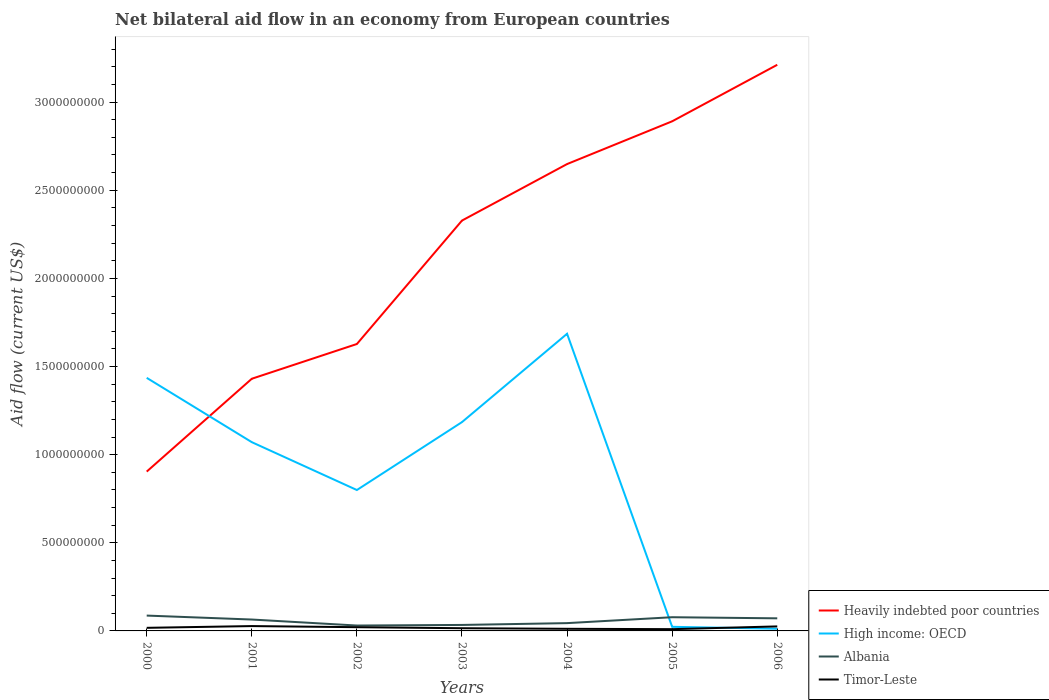Does the line corresponding to Timor-Leste intersect with the line corresponding to High income: OECD?
Offer a terse response. Yes. Across all years, what is the maximum net bilateral aid flow in High income: OECD?
Provide a short and direct response. 1.23e+07. What is the total net bilateral aid flow in Heavily indebted poor countries in the graph?
Offer a very short reply. -1.99e+09. What is the difference between the highest and the second highest net bilateral aid flow in High income: OECD?
Offer a terse response. 1.67e+09. Is the net bilateral aid flow in Albania strictly greater than the net bilateral aid flow in Heavily indebted poor countries over the years?
Your answer should be compact. Yes. How many years are there in the graph?
Offer a very short reply. 7. What is the difference between two consecutive major ticks on the Y-axis?
Your answer should be compact. 5.00e+08. Are the values on the major ticks of Y-axis written in scientific E-notation?
Provide a short and direct response. No. Does the graph contain any zero values?
Keep it short and to the point. No. Where does the legend appear in the graph?
Your answer should be compact. Bottom right. How are the legend labels stacked?
Provide a short and direct response. Vertical. What is the title of the graph?
Provide a short and direct response. Net bilateral aid flow in an economy from European countries. Does "Northern Mariana Islands" appear as one of the legend labels in the graph?
Offer a very short reply. No. What is the label or title of the Y-axis?
Offer a terse response. Aid flow (current US$). What is the Aid flow (current US$) in Heavily indebted poor countries in 2000?
Make the answer very short. 9.04e+08. What is the Aid flow (current US$) of High income: OECD in 2000?
Give a very brief answer. 1.44e+09. What is the Aid flow (current US$) in Albania in 2000?
Provide a succinct answer. 8.71e+07. What is the Aid flow (current US$) of Timor-Leste in 2000?
Ensure brevity in your answer.  1.75e+07. What is the Aid flow (current US$) in Heavily indebted poor countries in 2001?
Your answer should be very brief. 1.43e+09. What is the Aid flow (current US$) of High income: OECD in 2001?
Make the answer very short. 1.07e+09. What is the Aid flow (current US$) of Albania in 2001?
Your answer should be compact. 6.46e+07. What is the Aid flow (current US$) in Timor-Leste in 2001?
Make the answer very short. 2.75e+07. What is the Aid flow (current US$) in Heavily indebted poor countries in 2002?
Offer a terse response. 1.63e+09. What is the Aid flow (current US$) in High income: OECD in 2002?
Make the answer very short. 7.99e+08. What is the Aid flow (current US$) in Albania in 2002?
Give a very brief answer. 3.06e+07. What is the Aid flow (current US$) of Timor-Leste in 2002?
Give a very brief answer. 2.12e+07. What is the Aid flow (current US$) of Heavily indebted poor countries in 2003?
Your answer should be compact. 2.33e+09. What is the Aid flow (current US$) of High income: OECD in 2003?
Your response must be concise. 1.18e+09. What is the Aid flow (current US$) in Albania in 2003?
Keep it short and to the point. 3.39e+07. What is the Aid flow (current US$) of Timor-Leste in 2003?
Your answer should be compact. 1.53e+07. What is the Aid flow (current US$) of Heavily indebted poor countries in 2004?
Offer a terse response. 2.65e+09. What is the Aid flow (current US$) in High income: OECD in 2004?
Your answer should be very brief. 1.69e+09. What is the Aid flow (current US$) of Albania in 2004?
Give a very brief answer. 4.42e+07. What is the Aid flow (current US$) in Timor-Leste in 2004?
Keep it short and to the point. 1.21e+07. What is the Aid flow (current US$) of Heavily indebted poor countries in 2005?
Offer a terse response. 2.89e+09. What is the Aid flow (current US$) in High income: OECD in 2005?
Your answer should be compact. 2.33e+07. What is the Aid flow (current US$) of Albania in 2005?
Make the answer very short. 7.78e+07. What is the Aid flow (current US$) in Timor-Leste in 2005?
Provide a short and direct response. 9.97e+06. What is the Aid flow (current US$) in Heavily indebted poor countries in 2006?
Make the answer very short. 3.21e+09. What is the Aid flow (current US$) of High income: OECD in 2006?
Make the answer very short. 1.23e+07. What is the Aid flow (current US$) of Albania in 2006?
Offer a terse response. 7.14e+07. What is the Aid flow (current US$) in Timor-Leste in 2006?
Offer a very short reply. 2.56e+07. Across all years, what is the maximum Aid flow (current US$) in Heavily indebted poor countries?
Keep it short and to the point. 3.21e+09. Across all years, what is the maximum Aid flow (current US$) in High income: OECD?
Ensure brevity in your answer.  1.69e+09. Across all years, what is the maximum Aid flow (current US$) in Albania?
Give a very brief answer. 8.71e+07. Across all years, what is the maximum Aid flow (current US$) in Timor-Leste?
Keep it short and to the point. 2.75e+07. Across all years, what is the minimum Aid flow (current US$) in Heavily indebted poor countries?
Offer a very short reply. 9.04e+08. Across all years, what is the minimum Aid flow (current US$) of High income: OECD?
Offer a terse response. 1.23e+07. Across all years, what is the minimum Aid flow (current US$) of Albania?
Provide a short and direct response. 3.06e+07. Across all years, what is the minimum Aid flow (current US$) in Timor-Leste?
Provide a succinct answer. 9.97e+06. What is the total Aid flow (current US$) in Heavily indebted poor countries in the graph?
Offer a very short reply. 1.50e+1. What is the total Aid flow (current US$) of High income: OECD in the graph?
Your answer should be compact. 6.21e+09. What is the total Aid flow (current US$) of Albania in the graph?
Your response must be concise. 4.10e+08. What is the total Aid flow (current US$) of Timor-Leste in the graph?
Your response must be concise. 1.29e+08. What is the difference between the Aid flow (current US$) in Heavily indebted poor countries in 2000 and that in 2001?
Keep it short and to the point. -5.27e+08. What is the difference between the Aid flow (current US$) of High income: OECD in 2000 and that in 2001?
Your response must be concise. 3.65e+08. What is the difference between the Aid flow (current US$) of Albania in 2000 and that in 2001?
Offer a terse response. 2.25e+07. What is the difference between the Aid flow (current US$) in Timor-Leste in 2000 and that in 2001?
Your answer should be very brief. -9.96e+06. What is the difference between the Aid flow (current US$) of Heavily indebted poor countries in 2000 and that in 2002?
Your answer should be very brief. -7.24e+08. What is the difference between the Aid flow (current US$) of High income: OECD in 2000 and that in 2002?
Your response must be concise. 6.36e+08. What is the difference between the Aid flow (current US$) in Albania in 2000 and that in 2002?
Provide a short and direct response. 5.65e+07. What is the difference between the Aid flow (current US$) of Timor-Leste in 2000 and that in 2002?
Make the answer very short. -3.64e+06. What is the difference between the Aid flow (current US$) in Heavily indebted poor countries in 2000 and that in 2003?
Provide a succinct answer. -1.42e+09. What is the difference between the Aid flow (current US$) in High income: OECD in 2000 and that in 2003?
Your response must be concise. 2.51e+08. What is the difference between the Aid flow (current US$) in Albania in 2000 and that in 2003?
Keep it short and to the point. 5.32e+07. What is the difference between the Aid flow (current US$) in Timor-Leste in 2000 and that in 2003?
Offer a terse response. 2.21e+06. What is the difference between the Aid flow (current US$) of Heavily indebted poor countries in 2000 and that in 2004?
Your response must be concise. -1.74e+09. What is the difference between the Aid flow (current US$) of High income: OECD in 2000 and that in 2004?
Keep it short and to the point. -2.50e+08. What is the difference between the Aid flow (current US$) of Albania in 2000 and that in 2004?
Give a very brief answer. 4.28e+07. What is the difference between the Aid flow (current US$) of Timor-Leste in 2000 and that in 2004?
Give a very brief answer. 5.45e+06. What is the difference between the Aid flow (current US$) of Heavily indebted poor countries in 2000 and that in 2005?
Your response must be concise. -1.99e+09. What is the difference between the Aid flow (current US$) of High income: OECD in 2000 and that in 2005?
Offer a very short reply. 1.41e+09. What is the difference between the Aid flow (current US$) of Albania in 2000 and that in 2005?
Make the answer very short. 9.33e+06. What is the difference between the Aid flow (current US$) of Timor-Leste in 2000 and that in 2005?
Offer a very short reply. 7.56e+06. What is the difference between the Aid flow (current US$) in Heavily indebted poor countries in 2000 and that in 2006?
Ensure brevity in your answer.  -2.31e+09. What is the difference between the Aid flow (current US$) in High income: OECD in 2000 and that in 2006?
Your answer should be very brief. 1.42e+09. What is the difference between the Aid flow (current US$) of Albania in 2000 and that in 2006?
Provide a succinct answer. 1.57e+07. What is the difference between the Aid flow (current US$) of Timor-Leste in 2000 and that in 2006?
Provide a succinct answer. -8.06e+06. What is the difference between the Aid flow (current US$) of Heavily indebted poor countries in 2001 and that in 2002?
Offer a terse response. -1.97e+08. What is the difference between the Aid flow (current US$) of High income: OECD in 2001 and that in 2002?
Make the answer very short. 2.72e+08. What is the difference between the Aid flow (current US$) of Albania in 2001 and that in 2002?
Ensure brevity in your answer.  3.40e+07. What is the difference between the Aid flow (current US$) in Timor-Leste in 2001 and that in 2002?
Provide a short and direct response. 6.32e+06. What is the difference between the Aid flow (current US$) in Heavily indebted poor countries in 2001 and that in 2003?
Your response must be concise. -8.97e+08. What is the difference between the Aid flow (current US$) of High income: OECD in 2001 and that in 2003?
Keep it short and to the point. -1.14e+08. What is the difference between the Aid flow (current US$) of Albania in 2001 and that in 2003?
Make the answer very short. 3.07e+07. What is the difference between the Aid flow (current US$) in Timor-Leste in 2001 and that in 2003?
Your answer should be very brief. 1.22e+07. What is the difference between the Aid flow (current US$) in Heavily indebted poor countries in 2001 and that in 2004?
Give a very brief answer. -1.22e+09. What is the difference between the Aid flow (current US$) in High income: OECD in 2001 and that in 2004?
Your answer should be very brief. -6.15e+08. What is the difference between the Aid flow (current US$) in Albania in 2001 and that in 2004?
Your answer should be very brief. 2.04e+07. What is the difference between the Aid flow (current US$) in Timor-Leste in 2001 and that in 2004?
Keep it short and to the point. 1.54e+07. What is the difference between the Aid flow (current US$) in Heavily indebted poor countries in 2001 and that in 2005?
Your answer should be compact. -1.46e+09. What is the difference between the Aid flow (current US$) of High income: OECD in 2001 and that in 2005?
Give a very brief answer. 1.05e+09. What is the difference between the Aid flow (current US$) in Albania in 2001 and that in 2005?
Your answer should be compact. -1.32e+07. What is the difference between the Aid flow (current US$) of Timor-Leste in 2001 and that in 2005?
Your response must be concise. 1.75e+07. What is the difference between the Aid flow (current US$) in Heavily indebted poor countries in 2001 and that in 2006?
Your answer should be very brief. -1.78e+09. What is the difference between the Aid flow (current US$) in High income: OECD in 2001 and that in 2006?
Your answer should be very brief. 1.06e+09. What is the difference between the Aid flow (current US$) in Albania in 2001 and that in 2006?
Offer a very short reply. -6.81e+06. What is the difference between the Aid flow (current US$) of Timor-Leste in 2001 and that in 2006?
Provide a short and direct response. 1.90e+06. What is the difference between the Aid flow (current US$) of Heavily indebted poor countries in 2002 and that in 2003?
Offer a very short reply. -7.00e+08. What is the difference between the Aid flow (current US$) of High income: OECD in 2002 and that in 2003?
Your response must be concise. -3.85e+08. What is the difference between the Aid flow (current US$) of Albania in 2002 and that in 2003?
Make the answer very short. -3.29e+06. What is the difference between the Aid flow (current US$) of Timor-Leste in 2002 and that in 2003?
Provide a short and direct response. 5.85e+06. What is the difference between the Aid flow (current US$) of Heavily indebted poor countries in 2002 and that in 2004?
Make the answer very short. -1.02e+09. What is the difference between the Aid flow (current US$) of High income: OECD in 2002 and that in 2004?
Give a very brief answer. -8.86e+08. What is the difference between the Aid flow (current US$) of Albania in 2002 and that in 2004?
Your answer should be compact. -1.36e+07. What is the difference between the Aid flow (current US$) of Timor-Leste in 2002 and that in 2004?
Your answer should be very brief. 9.09e+06. What is the difference between the Aid flow (current US$) of Heavily indebted poor countries in 2002 and that in 2005?
Give a very brief answer. -1.26e+09. What is the difference between the Aid flow (current US$) of High income: OECD in 2002 and that in 2005?
Keep it short and to the point. 7.76e+08. What is the difference between the Aid flow (current US$) of Albania in 2002 and that in 2005?
Your answer should be very brief. -4.71e+07. What is the difference between the Aid flow (current US$) in Timor-Leste in 2002 and that in 2005?
Your response must be concise. 1.12e+07. What is the difference between the Aid flow (current US$) of Heavily indebted poor countries in 2002 and that in 2006?
Offer a very short reply. -1.58e+09. What is the difference between the Aid flow (current US$) of High income: OECD in 2002 and that in 2006?
Offer a very short reply. 7.87e+08. What is the difference between the Aid flow (current US$) in Albania in 2002 and that in 2006?
Provide a succinct answer. -4.08e+07. What is the difference between the Aid flow (current US$) of Timor-Leste in 2002 and that in 2006?
Provide a succinct answer. -4.42e+06. What is the difference between the Aid flow (current US$) in Heavily indebted poor countries in 2003 and that in 2004?
Keep it short and to the point. -3.21e+08. What is the difference between the Aid flow (current US$) of High income: OECD in 2003 and that in 2004?
Offer a very short reply. -5.01e+08. What is the difference between the Aid flow (current US$) of Albania in 2003 and that in 2004?
Your answer should be compact. -1.03e+07. What is the difference between the Aid flow (current US$) of Timor-Leste in 2003 and that in 2004?
Ensure brevity in your answer.  3.24e+06. What is the difference between the Aid flow (current US$) of Heavily indebted poor countries in 2003 and that in 2005?
Your response must be concise. -5.63e+08. What is the difference between the Aid flow (current US$) of High income: OECD in 2003 and that in 2005?
Make the answer very short. 1.16e+09. What is the difference between the Aid flow (current US$) of Albania in 2003 and that in 2005?
Make the answer very short. -4.38e+07. What is the difference between the Aid flow (current US$) in Timor-Leste in 2003 and that in 2005?
Your answer should be very brief. 5.35e+06. What is the difference between the Aid flow (current US$) in Heavily indebted poor countries in 2003 and that in 2006?
Your answer should be very brief. -8.84e+08. What is the difference between the Aid flow (current US$) in High income: OECD in 2003 and that in 2006?
Keep it short and to the point. 1.17e+09. What is the difference between the Aid flow (current US$) in Albania in 2003 and that in 2006?
Give a very brief answer. -3.75e+07. What is the difference between the Aid flow (current US$) in Timor-Leste in 2003 and that in 2006?
Provide a succinct answer. -1.03e+07. What is the difference between the Aid flow (current US$) of Heavily indebted poor countries in 2004 and that in 2005?
Provide a short and direct response. -2.43e+08. What is the difference between the Aid flow (current US$) in High income: OECD in 2004 and that in 2005?
Offer a very short reply. 1.66e+09. What is the difference between the Aid flow (current US$) in Albania in 2004 and that in 2005?
Offer a very short reply. -3.35e+07. What is the difference between the Aid flow (current US$) in Timor-Leste in 2004 and that in 2005?
Your answer should be very brief. 2.11e+06. What is the difference between the Aid flow (current US$) of Heavily indebted poor countries in 2004 and that in 2006?
Keep it short and to the point. -5.63e+08. What is the difference between the Aid flow (current US$) of High income: OECD in 2004 and that in 2006?
Give a very brief answer. 1.67e+09. What is the difference between the Aid flow (current US$) of Albania in 2004 and that in 2006?
Offer a very short reply. -2.72e+07. What is the difference between the Aid flow (current US$) in Timor-Leste in 2004 and that in 2006?
Give a very brief answer. -1.35e+07. What is the difference between the Aid flow (current US$) of Heavily indebted poor countries in 2005 and that in 2006?
Ensure brevity in your answer.  -3.21e+08. What is the difference between the Aid flow (current US$) of High income: OECD in 2005 and that in 2006?
Ensure brevity in your answer.  1.10e+07. What is the difference between the Aid flow (current US$) in Albania in 2005 and that in 2006?
Ensure brevity in your answer.  6.35e+06. What is the difference between the Aid flow (current US$) in Timor-Leste in 2005 and that in 2006?
Offer a terse response. -1.56e+07. What is the difference between the Aid flow (current US$) in Heavily indebted poor countries in 2000 and the Aid flow (current US$) in High income: OECD in 2001?
Your response must be concise. -1.67e+08. What is the difference between the Aid flow (current US$) of Heavily indebted poor countries in 2000 and the Aid flow (current US$) of Albania in 2001?
Keep it short and to the point. 8.39e+08. What is the difference between the Aid flow (current US$) in Heavily indebted poor countries in 2000 and the Aid flow (current US$) in Timor-Leste in 2001?
Your answer should be very brief. 8.76e+08. What is the difference between the Aid flow (current US$) of High income: OECD in 2000 and the Aid flow (current US$) of Albania in 2001?
Your answer should be compact. 1.37e+09. What is the difference between the Aid flow (current US$) in High income: OECD in 2000 and the Aid flow (current US$) in Timor-Leste in 2001?
Offer a terse response. 1.41e+09. What is the difference between the Aid flow (current US$) of Albania in 2000 and the Aid flow (current US$) of Timor-Leste in 2001?
Make the answer very short. 5.96e+07. What is the difference between the Aid flow (current US$) in Heavily indebted poor countries in 2000 and the Aid flow (current US$) in High income: OECD in 2002?
Ensure brevity in your answer.  1.05e+08. What is the difference between the Aid flow (current US$) of Heavily indebted poor countries in 2000 and the Aid flow (current US$) of Albania in 2002?
Your answer should be compact. 8.73e+08. What is the difference between the Aid flow (current US$) of Heavily indebted poor countries in 2000 and the Aid flow (current US$) of Timor-Leste in 2002?
Your answer should be compact. 8.83e+08. What is the difference between the Aid flow (current US$) in High income: OECD in 2000 and the Aid flow (current US$) in Albania in 2002?
Provide a succinct answer. 1.41e+09. What is the difference between the Aid flow (current US$) in High income: OECD in 2000 and the Aid flow (current US$) in Timor-Leste in 2002?
Give a very brief answer. 1.41e+09. What is the difference between the Aid flow (current US$) of Albania in 2000 and the Aid flow (current US$) of Timor-Leste in 2002?
Keep it short and to the point. 6.59e+07. What is the difference between the Aid flow (current US$) of Heavily indebted poor countries in 2000 and the Aid flow (current US$) of High income: OECD in 2003?
Give a very brief answer. -2.81e+08. What is the difference between the Aid flow (current US$) of Heavily indebted poor countries in 2000 and the Aid flow (current US$) of Albania in 2003?
Ensure brevity in your answer.  8.70e+08. What is the difference between the Aid flow (current US$) of Heavily indebted poor countries in 2000 and the Aid flow (current US$) of Timor-Leste in 2003?
Keep it short and to the point. 8.89e+08. What is the difference between the Aid flow (current US$) in High income: OECD in 2000 and the Aid flow (current US$) in Albania in 2003?
Your answer should be compact. 1.40e+09. What is the difference between the Aid flow (current US$) in High income: OECD in 2000 and the Aid flow (current US$) in Timor-Leste in 2003?
Provide a short and direct response. 1.42e+09. What is the difference between the Aid flow (current US$) of Albania in 2000 and the Aid flow (current US$) of Timor-Leste in 2003?
Provide a short and direct response. 7.18e+07. What is the difference between the Aid flow (current US$) in Heavily indebted poor countries in 2000 and the Aid flow (current US$) in High income: OECD in 2004?
Your response must be concise. -7.82e+08. What is the difference between the Aid flow (current US$) of Heavily indebted poor countries in 2000 and the Aid flow (current US$) of Albania in 2004?
Make the answer very short. 8.60e+08. What is the difference between the Aid flow (current US$) of Heavily indebted poor countries in 2000 and the Aid flow (current US$) of Timor-Leste in 2004?
Your answer should be very brief. 8.92e+08. What is the difference between the Aid flow (current US$) of High income: OECD in 2000 and the Aid flow (current US$) of Albania in 2004?
Give a very brief answer. 1.39e+09. What is the difference between the Aid flow (current US$) of High income: OECD in 2000 and the Aid flow (current US$) of Timor-Leste in 2004?
Make the answer very short. 1.42e+09. What is the difference between the Aid flow (current US$) in Albania in 2000 and the Aid flow (current US$) in Timor-Leste in 2004?
Your answer should be very brief. 7.50e+07. What is the difference between the Aid flow (current US$) of Heavily indebted poor countries in 2000 and the Aid flow (current US$) of High income: OECD in 2005?
Keep it short and to the point. 8.81e+08. What is the difference between the Aid flow (current US$) of Heavily indebted poor countries in 2000 and the Aid flow (current US$) of Albania in 2005?
Your response must be concise. 8.26e+08. What is the difference between the Aid flow (current US$) of Heavily indebted poor countries in 2000 and the Aid flow (current US$) of Timor-Leste in 2005?
Your answer should be compact. 8.94e+08. What is the difference between the Aid flow (current US$) in High income: OECD in 2000 and the Aid flow (current US$) in Albania in 2005?
Provide a short and direct response. 1.36e+09. What is the difference between the Aid flow (current US$) of High income: OECD in 2000 and the Aid flow (current US$) of Timor-Leste in 2005?
Your response must be concise. 1.43e+09. What is the difference between the Aid flow (current US$) of Albania in 2000 and the Aid flow (current US$) of Timor-Leste in 2005?
Offer a terse response. 7.71e+07. What is the difference between the Aid flow (current US$) in Heavily indebted poor countries in 2000 and the Aid flow (current US$) in High income: OECD in 2006?
Ensure brevity in your answer.  8.92e+08. What is the difference between the Aid flow (current US$) of Heavily indebted poor countries in 2000 and the Aid flow (current US$) of Albania in 2006?
Ensure brevity in your answer.  8.33e+08. What is the difference between the Aid flow (current US$) of Heavily indebted poor countries in 2000 and the Aid flow (current US$) of Timor-Leste in 2006?
Give a very brief answer. 8.78e+08. What is the difference between the Aid flow (current US$) in High income: OECD in 2000 and the Aid flow (current US$) in Albania in 2006?
Provide a short and direct response. 1.36e+09. What is the difference between the Aid flow (current US$) in High income: OECD in 2000 and the Aid flow (current US$) in Timor-Leste in 2006?
Ensure brevity in your answer.  1.41e+09. What is the difference between the Aid flow (current US$) in Albania in 2000 and the Aid flow (current US$) in Timor-Leste in 2006?
Make the answer very short. 6.15e+07. What is the difference between the Aid flow (current US$) of Heavily indebted poor countries in 2001 and the Aid flow (current US$) of High income: OECD in 2002?
Ensure brevity in your answer.  6.31e+08. What is the difference between the Aid flow (current US$) in Heavily indebted poor countries in 2001 and the Aid flow (current US$) in Albania in 2002?
Provide a short and direct response. 1.40e+09. What is the difference between the Aid flow (current US$) of Heavily indebted poor countries in 2001 and the Aid flow (current US$) of Timor-Leste in 2002?
Offer a very short reply. 1.41e+09. What is the difference between the Aid flow (current US$) of High income: OECD in 2001 and the Aid flow (current US$) of Albania in 2002?
Ensure brevity in your answer.  1.04e+09. What is the difference between the Aid flow (current US$) in High income: OECD in 2001 and the Aid flow (current US$) in Timor-Leste in 2002?
Offer a very short reply. 1.05e+09. What is the difference between the Aid flow (current US$) in Albania in 2001 and the Aid flow (current US$) in Timor-Leste in 2002?
Your answer should be very brief. 4.34e+07. What is the difference between the Aid flow (current US$) of Heavily indebted poor countries in 2001 and the Aid flow (current US$) of High income: OECD in 2003?
Provide a short and direct response. 2.46e+08. What is the difference between the Aid flow (current US$) in Heavily indebted poor countries in 2001 and the Aid flow (current US$) in Albania in 2003?
Offer a very short reply. 1.40e+09. What is the difference between the Aid flow (current US$) in Heavily indebted poor countries in 2001 and the Aid flow (current US$) in Timor-Leste in 2003?
Your answer should be compact. 1.42e+09. What is the difference between the Aid flow (current US$) of High income: OECD in 2001 and the Aid flow (current US$) of Albania in 2003?
Ensure brevity in your answer.  1.04e+09. What is the difference between the Aid flow (current US$) in High income: OECD in 2001 and the Aid flow (current US$) in Timor-Leste in 2003?
Offer a terse response. 1.06e+09. What is the difference between the Aid flow (current US$) in Albania in 2001 and the Aid flow (current US$) in Timor-Leste in 2003?
Offer a very short reply. 4.93e+07. What is the difference between the Aid flow (current US$) in Heavily indebted poor countries in 2001 and the Aid flow (current US$) in High income: OECD in 2004?
Your response must be concise. -2.55e+08. What is the difference between the Aid flow (current US$) in Heavily indebted poor countries in 2001 and the Aid flow (current US$) in Albania in 2004?
Provide a succinct answer. 1.39e+09. What is the difference between the Aid flow (current US$) of Heavily indebted poor countries in 2001 and the Aid flow (current US$) of Timor-Leste in 2004?
Ensure brevity in your answer.  1.42e+09. What is the difference between the Aid flow (current US$) in High income: OECD in 2001 and the Aid flow (current US$) in Albania in 2004?
Offer a terse response. 1.03e+09. What is the difference between the Aid flow (current US$) in High income: OECD in 2001 and the Aid flow (current US$) in Timor-Leste in 2004?
Ensure brevity in your answer.  1.06e+09. What is the difference between the Aid flow (current US$) in Albania in 2001 and the Aid flow (current US$) in Timor-Leste in 2004?
Make the answer very short. 5.25e+07. What is the difference between the Aid flow (current US$) in Heavily indebted poor countries in 2001 and the Aid flow (current US$) in High income: OECD in 2005?
Give a very brief answer. 1.41e+09. What is the difference between the Aid flow (current US$) in Heavily indebted poor countries in 2001 and the Aid flow (current US$) in Albania in 2005?
Your response must be concise. 1.35e+09. What is the difference between the Aid flow (current US$) in Heavily indebted poor countries in 2001 and the Aid flow (current US$) in Timor-Leste in 2005?
Your answer should be very brief. 1.42e+09. What is the difference between the Aid flow (current US$) of High income: OECD in 2001 and the Aid flow (current US$) of Albania in 2005?
Offer a terse response. 9.93e+08. What is the difference between the Aid flow (current US$) of High income: OECD in 2001 and the Aid flow (current US$) of Timor-Leste in 2005?
Your response must be concise. 1.06e+09. What is the difference between the Aid flow (current US$) of Albania in 2001 and the Aid flow (current US$) of Timor-Leste in 2005?
Offer a terse response. 5.46e+07. What is the difference between the Aid flow (current US$) in Heavily indebted poor countries in 2001 and the Aid flow (current US$) in High income: OECD in 2006?
Provide a short and direct response. 1.42e+09. What is the difference between the Aid flow (current US$) of Heavily indebted poor countries in 2001 and the Aid flow (current US$) of Albania in 2006?
Make the answer very short. 1.36e+09. What is the difference between the Aid flow (current US$) of Heavily indebted poor countries in 2001 and the Aid flow (current US$) of Timor-Leste in 2006?
Ensure brevity in your answer.  1.41e+09. What is the difference between the Aid flow (current US$) in High income: OECD in 2001 and the Aid flow (current US$) in Albania in 2006?
Provide a succinct answer. 1.00e+09. What is the difference between the Aid flow (current US$) of High income: OECD in 2001 and the Aid flow (current US$) of Timor-Leste in 2006?
Offer a terse response. 1.05e+09. What is the difference between the Aid flow (current US$) in Albania in 2001 and the Aid flow (current US$) in Timor-Leste in 2006?
Your answer should be compact. 3.90e+07. What is the difference between the Aid flow (current US$) in Heavily indebted poor countries in 2002 and the Aid flow (current US$) in High income: OECD in 2003?
Ensure brevity in your answer.  4.43e+08. What is the difference between the Aid flow (current US$) in Heavily indebted poor countries in 2002 and the Aid flow (current US$) in Albania in 2003?
Offer a terse response. 1.59e+09. What is the difference between the Aid flow (current US$) of Heavily indebted poor countries in 2002 and the Aid flow (current US$) of Timor-Leste in 2003?
Keep it short and to the point. 1.61e+09. What is the difference between the Aid flow (current US$) of High income: OECD in 2002 and the Aid flow (current US$) of Albania in 2003?
Give a very brief answer. 7.65e+08. What is the difference between the Aid flow (current US$) of High income: OECD in 2002 and the Aid flow (current US$) of Timor-Leste in 2003?
Keep it short and to the point. 7.84e+08. What is the difference between the Aid flow (current US$) in Albania in 2002 and the Aid flow (current US$) in Timor-Leste in 2003?
Your answer should be very brief. 1.53e+07. What is the difference between the Aid flow (current US$) of Heavily indebted poor countries in 2002 and the Aid flow (current US$) of High income: OECD in 2004?
Make the answer very short. -5.81e+07. What is the difference between the Aid flow (current US$) in Heavily indebted poor countries in 2002 and the Aid flow (current US$) in Albania in 2004?
Offer a terse response. 1.58e+09. What is the difference between the Aid flow (current US$) of Heavily indebted poor countries in 2002 and the Aid flow (current US$) of Timor-Leste in 2004?
Your response must be concise. 1.62e+09. What is the difference between the Aid flow (current US$) of High income: OECD in 2002 and the Aid flow (current US$) of Albania in 2004?
Keep it short and to the point. 7.55e+08. What is the difference between the Aid flow (current US$) of High income: OECD in 2002 and the Aid flow (current US$) of Timor-Leste in 2004?
Offer a terse response. 7.87e+08. What is the difference between the Aid flow (current US$) of Albania in 2002 and the Aid flow (current US$) of Timor-Leste in 2004?
Make the answer very short. 1.85e+07. What is the difference between the Aid flow (current US$) in Heavily indebted poor countries in 2002 and the Aid flow (current US$) in High income: OECD in 2005?
Offer a very short reply. 1.60e+09. What is the difference between the Aid flow (current US$) of Heavily indebted poor countries in 2002 and the Aid flow (current US$) of Albania in 2005?
Your response must be concise. 1.55e+09. What is the difference between the Aid flow (current US$) in Heavily indebted poor countries in 2002 and the Aid flow (current US$) in Timor-Leste in 2005?
Keep it short and to the point. 1.62e+09. What is the difference between the Aid flow (current US$) in High income: OECD in 2002 and the Aid flow (current US$) in Albania in 2005?
Your response must be concise. 7.22e+08. What is the difference between the Aid flow (current US$) in High income: OECD in 2002 and the Aid flow (current US$) in Timor-Leste in 2005?
Give a very brief answer. 7.89e+08. What is the difference between the Aid flow (current US$) in Albania in 2002 and the Aid flow (current US$) in Timor-Leste in 2005?
Your answer should be very brief. 2.06e+07. What is the difference between the Aid flow (current US$) of Heavily indebted poor countries in 2002 and the Aid flow (current US$) of High income: OECD in 2006?
Your response must be concise. 1.62e+09. What is the difference between the Aid flow (current US$) in Heavily indebted poor countries in 2002 and the Aid flow (current US$) in Albania in 2006?
Your response must be concise. 1.56e+09. What is the difference between the Aid flow (current US$) of Heavily indebted poor countries in 2002 and the Aid flow (current US$) of Timor-Leste in 2006?
Keep it short and to the point. 1.60e+09. What is the difference between the Aid flow (current US$) of High income: OECD in 2002 and the Aid flow (current US$) of Albania in 2006?
Your answer should be compact. 7.28e+08. What is the difference between the Aid flow (current US$) in High income: OECD in 2002 and the Aid flow (current US$) in Timor-Leste in 2006?
Your answer should be very brief. 7.74e+08. What is the difference between the Aid flow (current US$) in Albania in 2002 and the Aid flow (current US$) in Timor-Leste in 2006?
Make the answer very short. 5.03e+06. What is the difference between the Aid flow (current US$) in Heavily indebted poor countries in 2003 and the Aid flow (current US$) in High income: OECD in 2004?
Your answer should be very brief. 6.42e+08. What is the difference between the Aid flow (current US$) of Heavily indebted poor countries in 2003 and the Aid flow (current US$) of Albania in 2004?
Offer a terse response. 2.28e+09. What is the difference between the Aid flow (current US$) of Heavily indebted poor countries in 2003 and the Aid flow (current US$) of Timor-Leste in 2004?
Your answer should be compact. 2.32e+09. What is the difference between the Aid flow (current US$) in High income: OECD in 2003 and the Aid flow (current US$) in Albania in 2004?
Provide a short and direct response. 1.14e+09. What is the difference between the Aid flow (current US$) in High income: OECD in 2003 and the Aid flow (current US$) in Timor-Leste in 2004?
Provide a short and direct response. 1.17e+09. What is the difference between the Aid flow (current US$) in Albania in 2003 and the Aid flow (current US$) in Timor-Leste in 2004?
Your response must be concise. 2.18e+07. What is the difference between the Aid flow (current US$) of Heavily indebted poor countries in 2003 and the Aid flow (current US$) of High income: OECD in 2005?
Make the answer very short. 2.30e+09. What is the difference between the Aid flow (current US$) in Heavily indebted poor countries in 2003 and the Aid flow (current US$) in Albania in 2005?
Provide a succinct answer. 2.25e+09. What is the difference between the Aid flow (current US$) in Heavily indebted poor countries in 2003 and the Aid flow (current US$) in Timor-Leste in 2005?
Offer a terse response. 2.32e+09. What is the difference between the Aid flow (current US$) in High income: OECD in 2003 and the Aid flow (current US$) in Albania in 2005?
Your answer should be compact. 1.11e+09. What is the difference between the Aid flow (current US$) in High income: OECD in 2003 and the Aid flow (current US$) in Timor-Leste in 2005?
Make the answer very short. 1.17e+09. What is the difference between the Aid flow (current US$) of Albania in 2003 and the Aid flow (current US$) of Timor-Leste in 2005?
Ensure brevity in your answer.  2.39e+07. What is the difference between the Aid flow (current US$) of Heavily indebted poor countries in 2003 and the Aid flow (current US$) of High income: OECD in 2006?
Your answer should be very brief. 2.32e+09. What is the difference between the Aid flow (current US$) of Heavily indebted poor countries in 2003 and the Aid flow (current US$) of Albania in 2006?
Keep it short and to the point. 2.26e+09. What is the difference between the Aid flow (current US$) of Heavily indebted poor countries in 2003 and the Aid flow (current US$) of Timor-Leste in 2006?
Your answer should be very brief. 2.30e+09. What is the difference between the Aid flow (current US$) in High income: OECD in 2003 and the Aid flow (current US$) in Albania in 2006?
Offer a terse response. 1.11e+09. What is the difference between the Aid flow (current US$) in High income: OECD in 2003 and the Aid flow (current US$) in Timor-Leste in 2006?
Provide a succinct answer. 1.16e+09. What is the difference between the Aid flow (current US$) in Albania in 2003 and the Aid flow (current US$) in Timor-Leste in 2006?
Ensure brevity in your answer.  8.32e+06. What is the difference between the Aid flow (current US$) in Heavily indebted poor countries in 2004 and the Aid flow (current US$) in High income: OECD in 2005?
Provide a short and direct response. 2.63e+09. What is the difference between the Aid flow (current US$) of Heavily indebted poor countries in 2004 and the Aid flow (current US$) of Albania in 2005?
Your answer should be compact. 2.57e+09. What is the difference between the Aid flow (current US$) in Heavily indebted poor countries in 2004 and the Aid flow (current US$) in Timor-Leste in 2005?
Your answer should be very brief. 2.64e+09. What is the difference between the Aid flow (current US$) of High income: OECD in 2004 and the Aid flow (current US$) of Albania in 2005?
Offer a very short reply. 1.61e+09. What is the difference between the Aid flow (current US$) in High income: OECD in 2004 and the Aid flow (current US$) in Timor-Leste in 2005?
Ensure brevity in your answer.  1.68e+09. What is the difference between the Aid flow (current US$) of Albania in 2004 and the Aid flow (current US$) of Timor-Leste in 2005?
Your answer should be very brief. 3.43e+07. What is the difference between the Aid flow (current US$) of Heavily indebted poor countries in 2004 and the Aid flow (current US$) of High income: OECD in 2006?
Your answer should be very brief. 2.64e+09. What is the difference between the Aid flow (current US$) in Heavily indebted poor countries in 2004 and the Aid flow (current US$) in Albania in 2006?
Provide a short and direct response. 2.58e+09. What is the difference between the Aid flow (current US$) of Heavily indebted poor countries in 2004 and the Aid flow (current US$) of Timor-Leste in 2006?
Provide a succinct answer. 2.62e+09. What is the difference between the Aid flow (current US$) in High income: OECD in 2004 and the Aid flow (current US$) in Albania in 2006?
Offer a very short reply. 1.61e+09. What is the difference between the Aid flow (current US$) of High income: OECD in 2004 and the Aid flow (current US$) of Timor-Leste in 2006?
Keep it short and to the point. 1.66e+09. What is the difference between the Aid flow (current US$) in Albania in 2004 and the Aid flow (current US$) in Timor-Leste in 2006?
Offer a very short reply. 1.86e+07. What is the difference between the Aid flow (current US$) of Heavily indebted poor countries in 2005 and the Aid flow (current US$) of High income: OECD in 2006?
Provide a succinct answer. 2.88e+09. What is the difference between the Aid flow (current US$) in Heavily indebted poor countries in 2005 and the Aid flow (current US$) in Albania in 2006?
Offer a very short reply. 2.82e+09. What is the difference between the Aid flow (current US$) in Heavily indebted poor countries in 2005 and the Aid flow (current US$) in Timor-Leste in 2006?
Your response must be concise. 2.87e+09. What is the difference between the Aid flow (current US$) in High income: OECD in 2005 and the Aid flow (current US$) in Albania in 2006?
Your answer should be very brief. -4.81e+07. What is the difference between the Aid flow (current US$) of High income: OECD in 2005 and the Aid flow (current US$) of Timor-Leste in 2006?
Provide a short and direct response. -2.31e+06. What is the difference between the Aid flow (current US$) in Albania in 2005 and the Aid flow (current US$) in Timor-Leste in 2006?
Give a very brief answer. 5.22e+07. What is the average Aid flow (current US$) of Heavily indebted poor countries per year?
Give a very brief answer. 2.15e+09. What is the average Aid flow (current US$) of High income: OECD per year?
Keep it short and to the point. 8.87e+08. What is the average Aid flow (current US$) in Albania per year?
Ensure brevity in your answer.  5.85e+07. What is the average Aid flow (current US$) of Timor-Leste per year?
Your response must be concise. 1.84e+07. In the year 2000, what is the difference between the Aid flow (current US$) of Heavily indebted poor countries and Aid flow (current US$) of High income: OECD?
Offer a terse response. -5.32e+08. In the year 2000, what is the difference between the Aid flow (current US$) in Heavily indebted poor countries and Aid flow (current US$) in Albania?
Keep it short and to the point. 8.17e+08. In the year 2000, what is the difference between the Aid flow (current US$) in Heavily indebted poor countries and Aid flow (current US$) in Timor-Leste?
Ensure brevity in your answer.  8.86e+08. In the year 2000, what is the difference between the Aid flow (current US$) of High income: OECD and Aid flow (current US$) of Albania?
Make the answer very short. 1.35e+09. In the year 2000, what is the difference between the Aid flow (current US$) of High income: OECD and Aid flow (current US$) of Timor-Leste?
Provide a short and direct response. 1.42e+09. In the year 2000, what is the difference between the Aid flow (current US$) in Albania and Aid flow (current US$) in Timor-Leste?
Your response must be concise. 6.96e+07. In the year 2001, what is the difference between the Aid flow (current US$) of Heavily indebted poor countries and Aid flow (current US$) of High income: OECD?
Offer a terse response. 3.60e+08. In the year 2001, what is the difference between the Aid flow (current US$) in Heavily indebted poor countries and Aid flow (current US$) in Albania?
Ensure brevity in your answer.  1.37e+09. In the year 2001, what is the difference between the Aid flow (current US$) of Heavily indebted poor countries and Aid flow (current US$) of Timor-Leste?
Offer a very short reply. 1.40e+09. In the year 2001, what is the difference between the Aid flow (current US$) in High income: OECD and Aid flow (current US$) in Albania?
Offer a terse response. 1.01e+09. In the year 2001, what is the difference between the Aid flow (current US$) of High income: OECD and Aid flow (current US$) of Timor-Leste?
Give a very brief answer. 1.04e+09. In the year 2001, what is the difference between the Aid flow (current US$) in Albania and Aid flow (current US$) in Timor-Leste?
Offer a very short reply. 3.71e+07. In the year 2002, what is the difference between the Aid flow (current US$) in Heavily indebted poor countries and Aid flow (current US$) in High income: OECD?
Offer a very short reply. 8.28e+08. In the year 2002, what is the difference between the Aid flow (current US$) in Heavily indebted poor countries and Aid flow (current US$) in Albania?
Your answer should be compact. 1.60e+09. In the year 2002, what is the difference between the Aid flow (current US$) of Heavily indebted poor countries and Aid flow (current US$) of Timor-Leste?
Keep it short and to the point. 1.61e+09. In the year 2002, what is the difference between the Aid flow (current US$) of High income: OECD and Aid flow (current US$) of Albania?
Your answer should be very brief. 7.69e+08. In the year 2002, what is the difference between the Aid flow (current US$) of High income: OECD and Aid flow (current US$) of Timor-Leste?
Give a very brief answer. 7.78e+08. In the year 2002, what is the difference between the Aid flow (current US$) in Albania and Aid flow (current US$) in Timor-Leste?
Make the answer very short. 9.45e+06. In the year 2003, what is the difference between the Aid flow (current US$) of Heavily indebted poor countries and Aid flow (current US$) of High income: OECD?
Provide a succinct answer. 1.14e+09. In the year 2003, what is the difference between the Aid flow (current US$) in Heavily indebted poor countries and Aid flow (current US$) in Albania?
Make the answer very short. 2.29e+09. In the year 2003, what is the difference between the Aid flow (current US$) of Heavily indebted poor countries and Aid flow (current US$) of Timor-Leste?
Offer a very short reply. 2.31e+09. In the year 2003, what is the difference between the Aid flow (current US$) in High income: OECD and Aid flow (current US$) in Albania?
Your answer should be very brief. 1.15e+09. In the year 2003, what is the difference between the Aid flow (current US$) in High income: OECD and Aid flow (current US$) in Timor-Leste?
Offer a terse response. 1.17e+09. In the year 2003, what is the difference between the Aid flow (current US$) of Albania and Aid flow (current US$) of Timor-Leste?
Your answer should be very brief. 1.86e+07. In the year 2004, what is the difference between the Aid flow (current US$) of Heavily indebted poor countries and Aid flow (current US$) of High income: OECD?
Provide a short and direct response. 9.63e+08. In the year 2004, what is the difference between the Aid flow (current US$) in Heavily indebted poor countries and Aid flow (current US$) in Albania?
Offer a very short reply. 2.60e+09. In the year 2004, what is the difference between the Aid flow (current US$) in Heavily indebted poor countries and Aid flow (current US$) in Timor-Leste?
Provide a short and direct response. 2.64e+09. In the year 2004, what is the difference between the Aid flow (current US$) of High income: OECD and Aid flow (current US$) of Albania?
Your response must be concise. 1.64e+09. In the year 2004, what is the difference between the Aid flow (current US$) in High income: OECD and Aid flow (current US$) in Timor-Leste?
Ensure brevity in your answer.  1.67e+09. In the year 2004, what is the difference between the Aid flow (current US$) of Albania and Aid flow (current US$) of Timor-Leste?
Offer a terse response. 3.22e+07. In the year 2005, what is the difference between the Aid flow (current US$) in Heavily indebted poor countries and Aid flow (current US$) in High income: OECD?
Offer a terse response. 2.87e+09. In the year 2005, what is the difference between the Aid flow (current US$) in Heavily indebted poor countries and Aid flow (current US$) in Albania?
Your answer should be very brief. 2.81e+09. In the year 2005, what is the difference between the Aid flow (current US$) in Heavily indebted poor countries and Aid flow (current US$) in Timor-Leste?
Your answer should be very brief. 2.88e+09. In the year 2005, what is the difference between the Aid flow (current US$) in High income: OECD and Aid flow (current US$) in Albania?
Offer a very short reply. -5.45e+07. In the year 2005, what is the difference between the Aid flow (current US$) of High income: OECD and Aid flow (current US$) of Timor-Leste?
Keep it short and to the point. 1.33e+07. In the year 2005, what is the difference between the Aid flow (current US$) of Albania and Aid flow (current US$) of Timor-Leste?
Make the answer very short. 6.78e+07. In the year 2006, what is the difference between the Aid flow (current US$) in Heavily indebted poor countries and Aid flow (current US$) in High income: OECD?
Provide a succinct answer. 3.20e+09. In the year 2006, what is the difference between the Aid flow (current US$) of Heavily indebted poor countries and Aid flow (current US$) of Albania?
Offer a terse response. 3.14e+09. In the year 2006, what is the difference between the Aid flow (current US$) in Heavily indebted poor countries and Aid flow (current US$) in Timor-Leste?
Provide a short and direct response. 3.19e+09. In the year 2006, what is the difference between the Aid flow (current US$) in High income: OECD and Aid flow (current US$) in Albania?
Keep it short and to the point. -5.91e+07. In the year 2006, what is the difference between the Aid flow (current US$) in High income: OECD and Aid flow (current US$) in Timor-Leste?
Ensure brevity in your answer.  -1.33e+07. In the year 2006, what is the difference between the Aid flow (current US$) of Albania and Aid flow (current US$) of Timor-Leste?
Offer a very short reply. 4.58e+07. What is the ratio of the Aid flow (current US$) in Heavily indebted poor countries in 2000 to that in 2001?
Keep it short and to the point. 0.63. What is the ratio of the Aid flow (current US$) in High income: OECD in 2000 to that in 2001?
Ensure brevity in your answer.  1.34. What is the ratio of the Aid flow (current US$) of Albania in 2000 to that in 2001?
Keep it short and to the point. 1.35. What is the ratio of the Aid flow (current US$) in Timor-Leste in 2000 to that in 2001?
Offer a very short reply. 0.64. What is the ratio of the Aid flow (current US$) in Heavily indebted poor countries in 2000 to that in 2002?
Your answer should be compact. 0.56. What is the ratio of the Aid flow (current US$) in High income: OECD in 2000 to that in 2002?
Provide a succinct answer. 1.8. What is the ratio of the Aid flow (current US$) of Albania in 2000 to that in 2002?
Your answer should be very brief. 2.84. What is the ratio of the Aid flow (current US$) of Timor-Leste in 2000 to that in 2002?
Your answer should be compact. 0.83. What is the ratio of the Aid flow (current US$) of Heavily indebted poor countries in 2000 to that in 2003?
Offer a very short reply. 0.39. What is the ratio of the Aid flow (current US$) of High income: OECD in 2000 to that in 2003?
Provide a short and direct response. 1.21. What is the ratio of the Aid flow (current US$) in Albania in 2000 to that in 2003?
Offer a terse response. 2.57. What is the ratio of the Aid flow (current US$) of Timor-Leste in 2000 to that in 2003?
Offer a very short reply. 1.14. What is the ratio of the Aid flow (current US$) of Heavily indebted poor countries in 2000 to that in 2004?
Offer a terse response. 0.34. What is the ratio of the Aid flow (current US$) in High income: OECD in 2000 to that in 2004?
Keep it short and to the point. 0.85. What is the ratio of the Aid flow (current US$) of Albania in 2000 to that in 2004?
Your answer should be compact. 1.97. What is the ratio of the Aid flow (current US$) in Timor-Leste in 2000 to that in 2004?
Offer a terse response. 1.45. What is the ratio of the Aid flow (current US$) of Heavily indebted poor countries in 2000 to that in 2005?
Your answer should be compact. 0.31. What is the ratio of the Aid flow (current US$) in High income: OECD in 2000 to that in 2005?
Your answer should be very brief. 61.67. What is the ratio of the Aid flow (current US$) in Albania in 2000 to that in 2005?
Make the answer very short. 1.12. What is the ratio of the Aid flow (current US$) in Timor-Leste in 2000 to that in 2005?
Your answer should be compact. 1.76. What is the ratio of the Aid flow (current US$) in Heavily indebted poor countries in 2000 to that in 2006?
Keep it short and to the point. 0.28. What is the ratio of the Aid flow (current US$) of High income: OECD in 2000 to that in 2006?
Ensure brevity in your answer.  116.73. What is the ratio of the Aid flow (current US$) of Albania in 2000 to that in 2006?
Keep it short and to the point. 1.22. What is the ratio of the Aid flow (current US$) in Timor-Leste in 2000 to that in 2006?
Give a very brief answer. 0.69. What is the ratio of the Aid flow (current US$) in Heavily indebted poor countries in 2001 to that in 2002?
Give a very brief answer. 0.88. What is the ratio of the Aid flow (current US$) in High income: OECD in 2001 to that in 2002?
Offer a very short reply. 1.34. What is the ratio of the Aid flow (current US$) of Albania in 2001 to that in 2002?
Make the answer very short. 2.11. What is the ratio of the Aid flow (current US$) in Timor-Leste in 2001 to that in 2002?
Ensure brevity in your answer.  1.3. What is the ratio of the Aid flow (current US$) in Heavily indebted poor countries in 2001 to that in 2003?
Provide a short and direct response. 0.61. What is the ratio of the Aid flow (current US$) of High income: OECD in 2001 to that in 2003?
Provide a short and direct response. 0.9. What is the ratio of the Aid flow (current US$) of Albania in 2001 to that in 2003?
Keep it short and to the point. 1.9. What is the ratio of the Aid flow (current US$) of Timor-Leste in 2001 to that in 2003?
Provide a succinct answer. 1.79. What is the ratio of the Aid flow (current US$) of Heavily indebted poor countries in 2001 to that in 2004?
Ensure brevity in your answer.  0.54. What is the ratio of the Aid flow (current US$) in High income: OECD in 2001 to that in 2004?
Your answer should be very brief. 0.64. What is the ratio of the Aid flow (current US$) in Albania in 2001 to that in 2004?
Keep it short and to the point. 1.46. What is the ratio of the Aid flow (current US$) in Timor-Leste in 2001 to that in 2004?
Ensure brevity in your answer.  2.28. What is the ratio of the Aid flow (current US$) in Heavily indebted poor countries in 2001 to that in 2005?
Your response must be concise. 0.49. What is the ratio of the Aid flow (current US$) of High income: OECD in 2001 to that in 2005?
Your answer should be compact. 46. What is the ratio of the Aid flow (current US$) in Albania in 2001 to that in 2005?
Offer a very short reply. 0.83. What is the ratio of the Aid flow (current US$) of Timor-Leste in 2001 to that in 2005?
Keep it short and to the point. 2.76. What is the ratio of the Aid flow (current US$) in Heavily indebted poor countries in 2001 to that in 2006?
Your response must be concise. 0.45. What is the ratio of the Aid flow (current US$) of High income: OECD in 2001 to that in 2006?
Provide a succinct answer. 87.07. What is the ratio of the Aid flow (current US$) in Albania in 2001 to that in 2006?
Your response must be concise. 0.9. What is the ratio of the Aid flow (current US$) of Timor-Leste in 2001 to that in 2006?
Keep it short and to the point. 1.07. What is the ratio of the Aid flow (current US$) in Heavily indebted poor countries in 2002 to that in 2003?
Offer a terse response. 0.7. What is the ratio of the Aid flow (current US$) in High income: OECD in 2002 to that in 2003?
Offer a terse response. 0.67. What is the ratio of the Aid flow (current US$) in Albania in 2002 to that in 2003?
Your answer should be compact. 0.9. What is the ratio of the Aid flow (current US$) in Timor-Leste in 2002 to that in 2003?
Offer a terse response. 1.38. What is the ratio of the Aid flow (current US$) of Heavily indebted poor countries in 2002 to that in 2004?
Your response must be concise. 0.61. What is the ratio of the Aid flow (current US$) of High income: OECD in 2002 to that in 2004?
Give a very brief answer. 0.47. What is the ratio of the Aid flow (current US$) of Albania in 2002 to that in 2004?
Provide a short and direct response. 0.69. What is the ratio of the Aid flow (current US$) of Timor-Leste in 2002 to that in 2004?
Keep it short and to the point. 1.75. What is the ratio of the Aid flow (current US$) of Heavily indebted poor countries in 2002 to that in 2005?
Keep it short and to the point. 0.56. What is the ratio of the Aid flow (current US$) of High income: OECD in 2002 to that in 2005?
Provide a succinct answer. 34.34. What is the ratio of the Aid flow (current US$) in Albania in 2002 to that in 2005?
Your answer should be compact. 0.39. What is the ratio of the Aid flow (current US$) of Timor-Leste in 2002 to that in 2005?
Provide a succinct answer. 2.12. What is the ratio of the Aid flow (current US$) of Heavily indebted poor countries in 2002 to that in 2006?
Offer a very short reply. 0.51. What is the ratio of the Aid flow (current US$) in High income: OECD in 2002 to that in 2006?
Your answer should be very brief. 64.99. What is the ratio of the Aid flow (current US$) of Albania in 2002 to that in 2006?
Provide a succinct answer. 0.43. What is the ratio of the Aid flow (current US$) in Timor-Leste in 2002 to that in 2006?
Your answer should be very brief. 0.83. What is the ratio of the Aid flow (current US$) in Heavily indebted poor countries in 2003 to that in 2004?
Your answer should be compact. 0.88. What is the ratio of the Aid flow (current US$) in High income: OECD in 2003 to that in 2004?
Keep it short and to the point. 0.7. What is the ratio of the Aid flow (current US$) of Albania in 2003 to that in 2004?
Ensure brevity in your answer.  0.77. What is the ratio of the Aid flow (current US$) of Timor-Leste in 2003 to that in 2004?
Keep it short and to the point. 1.27. What is the ratio of the Aid flow (current US$) of Heavily indebted poor countries in 2003 to that in 2005?
Keep it short and to the point. 0.81. What is the ratio of the Aid flow (current US$) of High income: OECD in 2003 to that in 2005?
Offer a very short reply. 50.89. What is the ratio of the Aid flow (current US$) in Albania in 2003 to that in 2005?
Make the answer very short. 0.44. What is the ratio of the Aid flow (current US$) in Timor-Leste in 2003 to that in 2005?
Offer a very short reply. 1.54. What is the ratio of the Aid flow (current US$) in Heavily indebted poor countries in 2003 to that in 2006?
Make the answer very short. 0.72. What is the ratio of the Aid flow (current US$) in High income: OECD in 2003 to that in 2006?
Provide a succinct answer. 96.31. What is the ratio of the Aid flow (current US$) in Albania in 2003 to that in 2006?
Your answer should be compact. 0.47. What is the ratio of the Aid flow (current US$) of Timor-Leste in 2003 to that in 2006?
Offer a terse response. 0.6. What is the ratio of the Aid flow (current US$) of Heavily indebted poor countries in 2004 to that in 2005?
Offer a terse response. 0.92. What is the ratio of the Aid flow (current US$) in High income: OECD in 2004 to that in 2005?
Your answer should be very brief. 72.41. What is the ratio of the Aid flow (current US$) in Albania in 2004 to that in 2005?
Offer a very short reply. 0.57. What is the ratio of the Aid flow (current US$) in Timor-Leste in 2004 to that in 2005?
Your answer should be compact. 1.21. What is the ratio of the Aid flow (current US$) of Heavily indebted poor countries in 2004 to that in 2006?
Offer a terse response. 0.82. What is the ratio of the Aid flow (current US$) of High income: OECD in 2004 to that in 2006?
Offer a terse response. 137.06. What is the ratio of the Aid flow (current US$) in Albania in 2004 to that in 2006?
Offer a terse response. 0.62. What is the ratio of the Aid flow (current US$) of Timor-Leste in 2004 to that in 2006?
Make the answer very short. 0.47. What is the ratio of the Aid flow (current US$) in Heavily indebted poor countries in 2005 to that in 2006?
Keep it short and to the point. 0.9. What is the ratio of the Aid flow (current US$) in High income: OECD in 2005 to that in 2006?
Your answer should be very brief. 1.89. What is the ratio of the Aid flow (current US$) of Albania in 2005 to that in 2006?
Your answer should be compact. 1.09. What is the ratio of the Aid flow (current US$) of Timor-Leste in 2005 to that in 2006?
Make the answer very short. 0.39. What is the difference between the highest and the second highest Aid flow (current US$) in Heavily indebted poor countries?
Give a very brief answer. 3.21e+08. What is the difference between the highest and the second highest Aid flow (current US$) of High income: OECD?
Your answer should be very brief. 2.50e+08. What is the difference between the highest and the second highest Aid flow (current US$) of Albania?
Offer a terse response. 9.33e+06. What is the difference between the highest and the second highest Aid flow (current US$) in Timor-Leste?
Give a very brief answer. 1.90e+06. What is the difference between the highest and the lowest Aid flow (current US$) of Heavily indebted poor countries?
Your answer should be very brief. 2.31e+09. What is the difference between the highest and the lowest Aid flow (current US$) in High income: OECD?
Your answer should be very brief. 1.67e+09. What is the difference between the highest and the lowest Aid flow (current US$) of Albania?
Provide a succinct answer. 5.65e+07. What is the difference between the highest and the lowest Aid flow (current US$) in Timor-Leste?
Your response must be concise. 1.75e+07. 